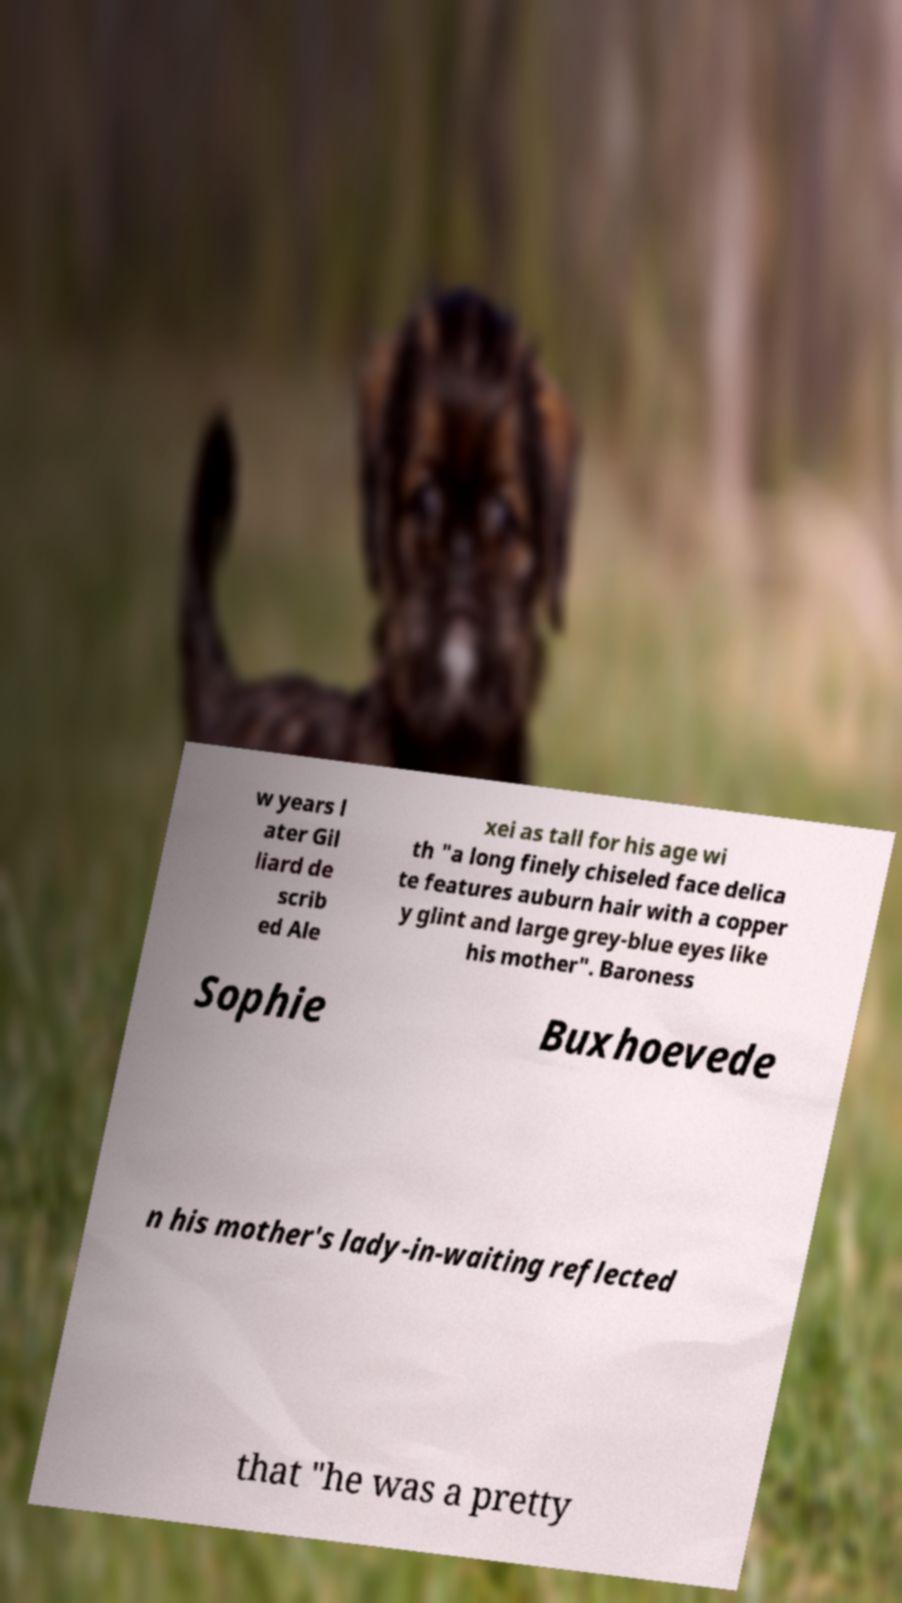Can you accurately transcribe the text from the provided image for me? w years l ater Gil liard de scrib ed Ale xei as tall for his age wi th "a long finely chiseled face delica te features auburn hair with a copper y glint and large grey-blue eyes like his mother". Baroness Sophie Buxhoevede n his mother's lady-in-waiting reflected that "he was a pretty 